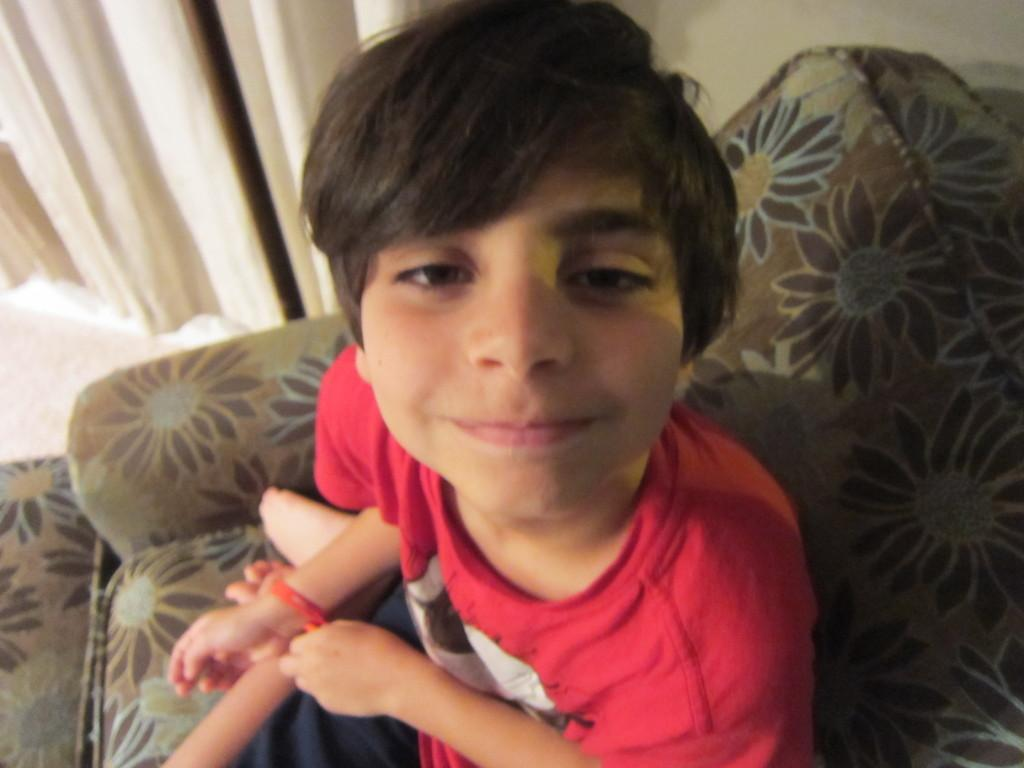What is the main subject in the foreground of the image? There is a boy in the foreground of the image. What is the boy doing in the image? The boy is sitting on a sofa. What can be seen in the background of the image? There is a wall in the background of the image. Is there any window treatment visible in the image? Yes, there is a curtain associated with the wall in the background. What direction is the boy's aunt facing in the image? There is no aunt present in the image, so it is not possible to determine the direction she might be facing. 